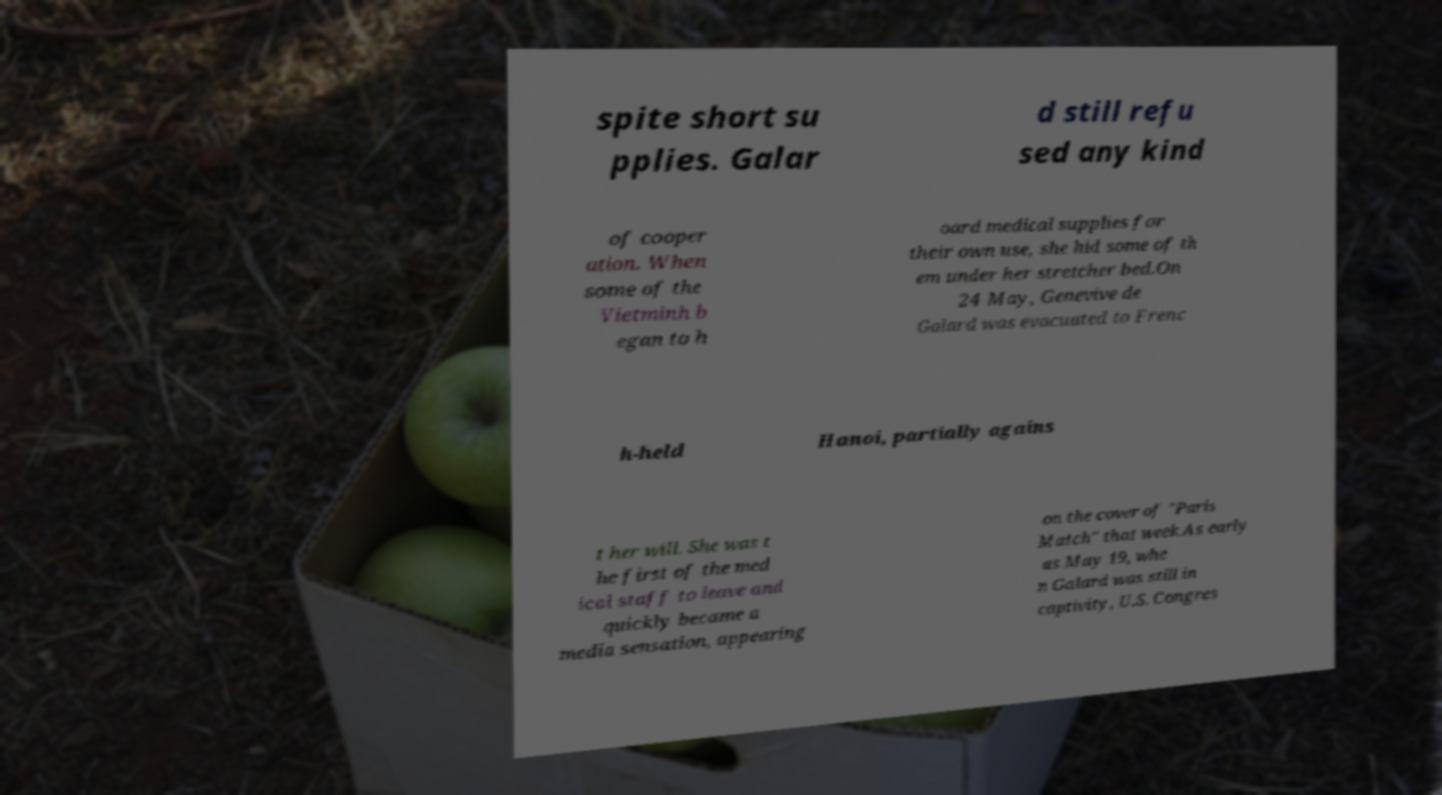Could you extract and type out the text from this image? spite short su pplies. Galar d still refu sed any kind of cooper ation. When some of the Vietminh b egan to h oard medical supplies for their own use, she hid some of th em under her stretcher bed.On 24 May, Genevive de Galard was evacuated to Frenc h-held Hanoi, partially agains t her will. She was t he first of the med ical staff to leave and quickly became a media sensation, appearing on the cover of "Paris Match" that week.As early as May 19, whe n Galard was still in captivity, U.S. Congres 